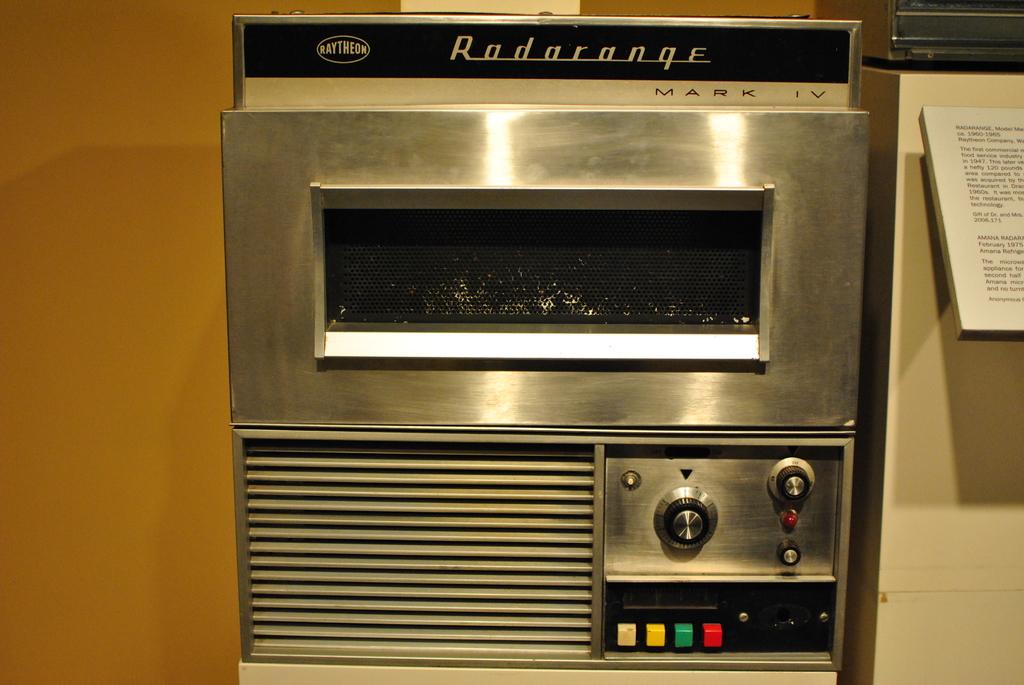What is written in blue above this box?
Your response must be concise. Radarange. 